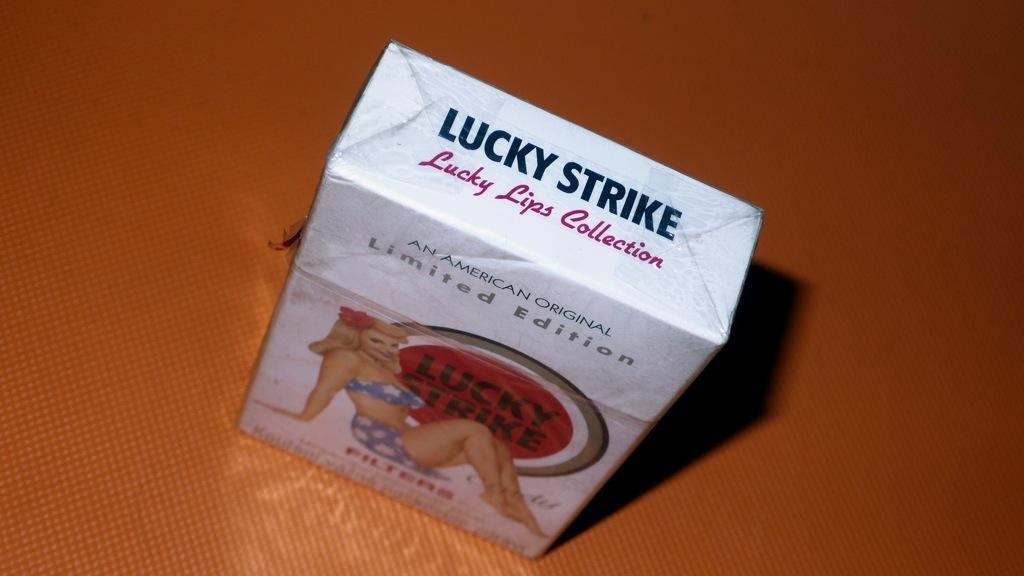Please provide a concise description of this image. In the center of the image, we can see a box on the table. 